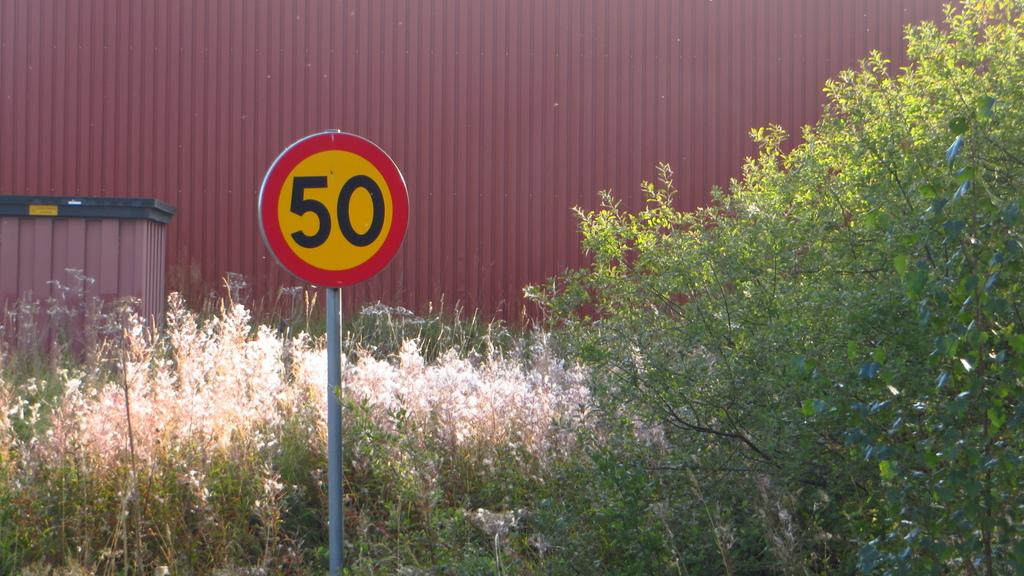<image>
Render a clear and concise summary of the photo. A round number 50 sign stands tall in front of a strip of weeds. 